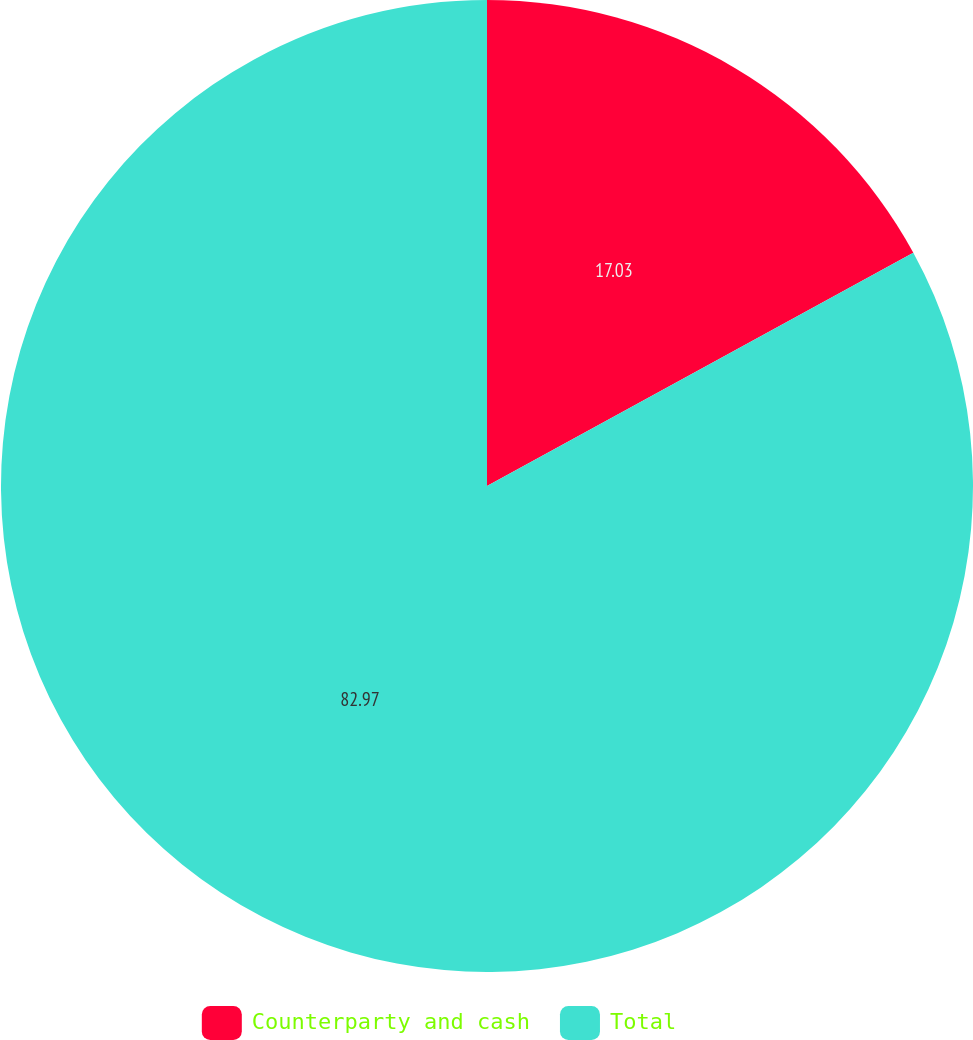Convert chart. <chart><loc_0><loc_0><loc_500><loc_500><pie_chart><fcel>Counterparty and cash<fcel>Total<nl><fcel>17.03%<fcel>82.97%<nl></chart> 